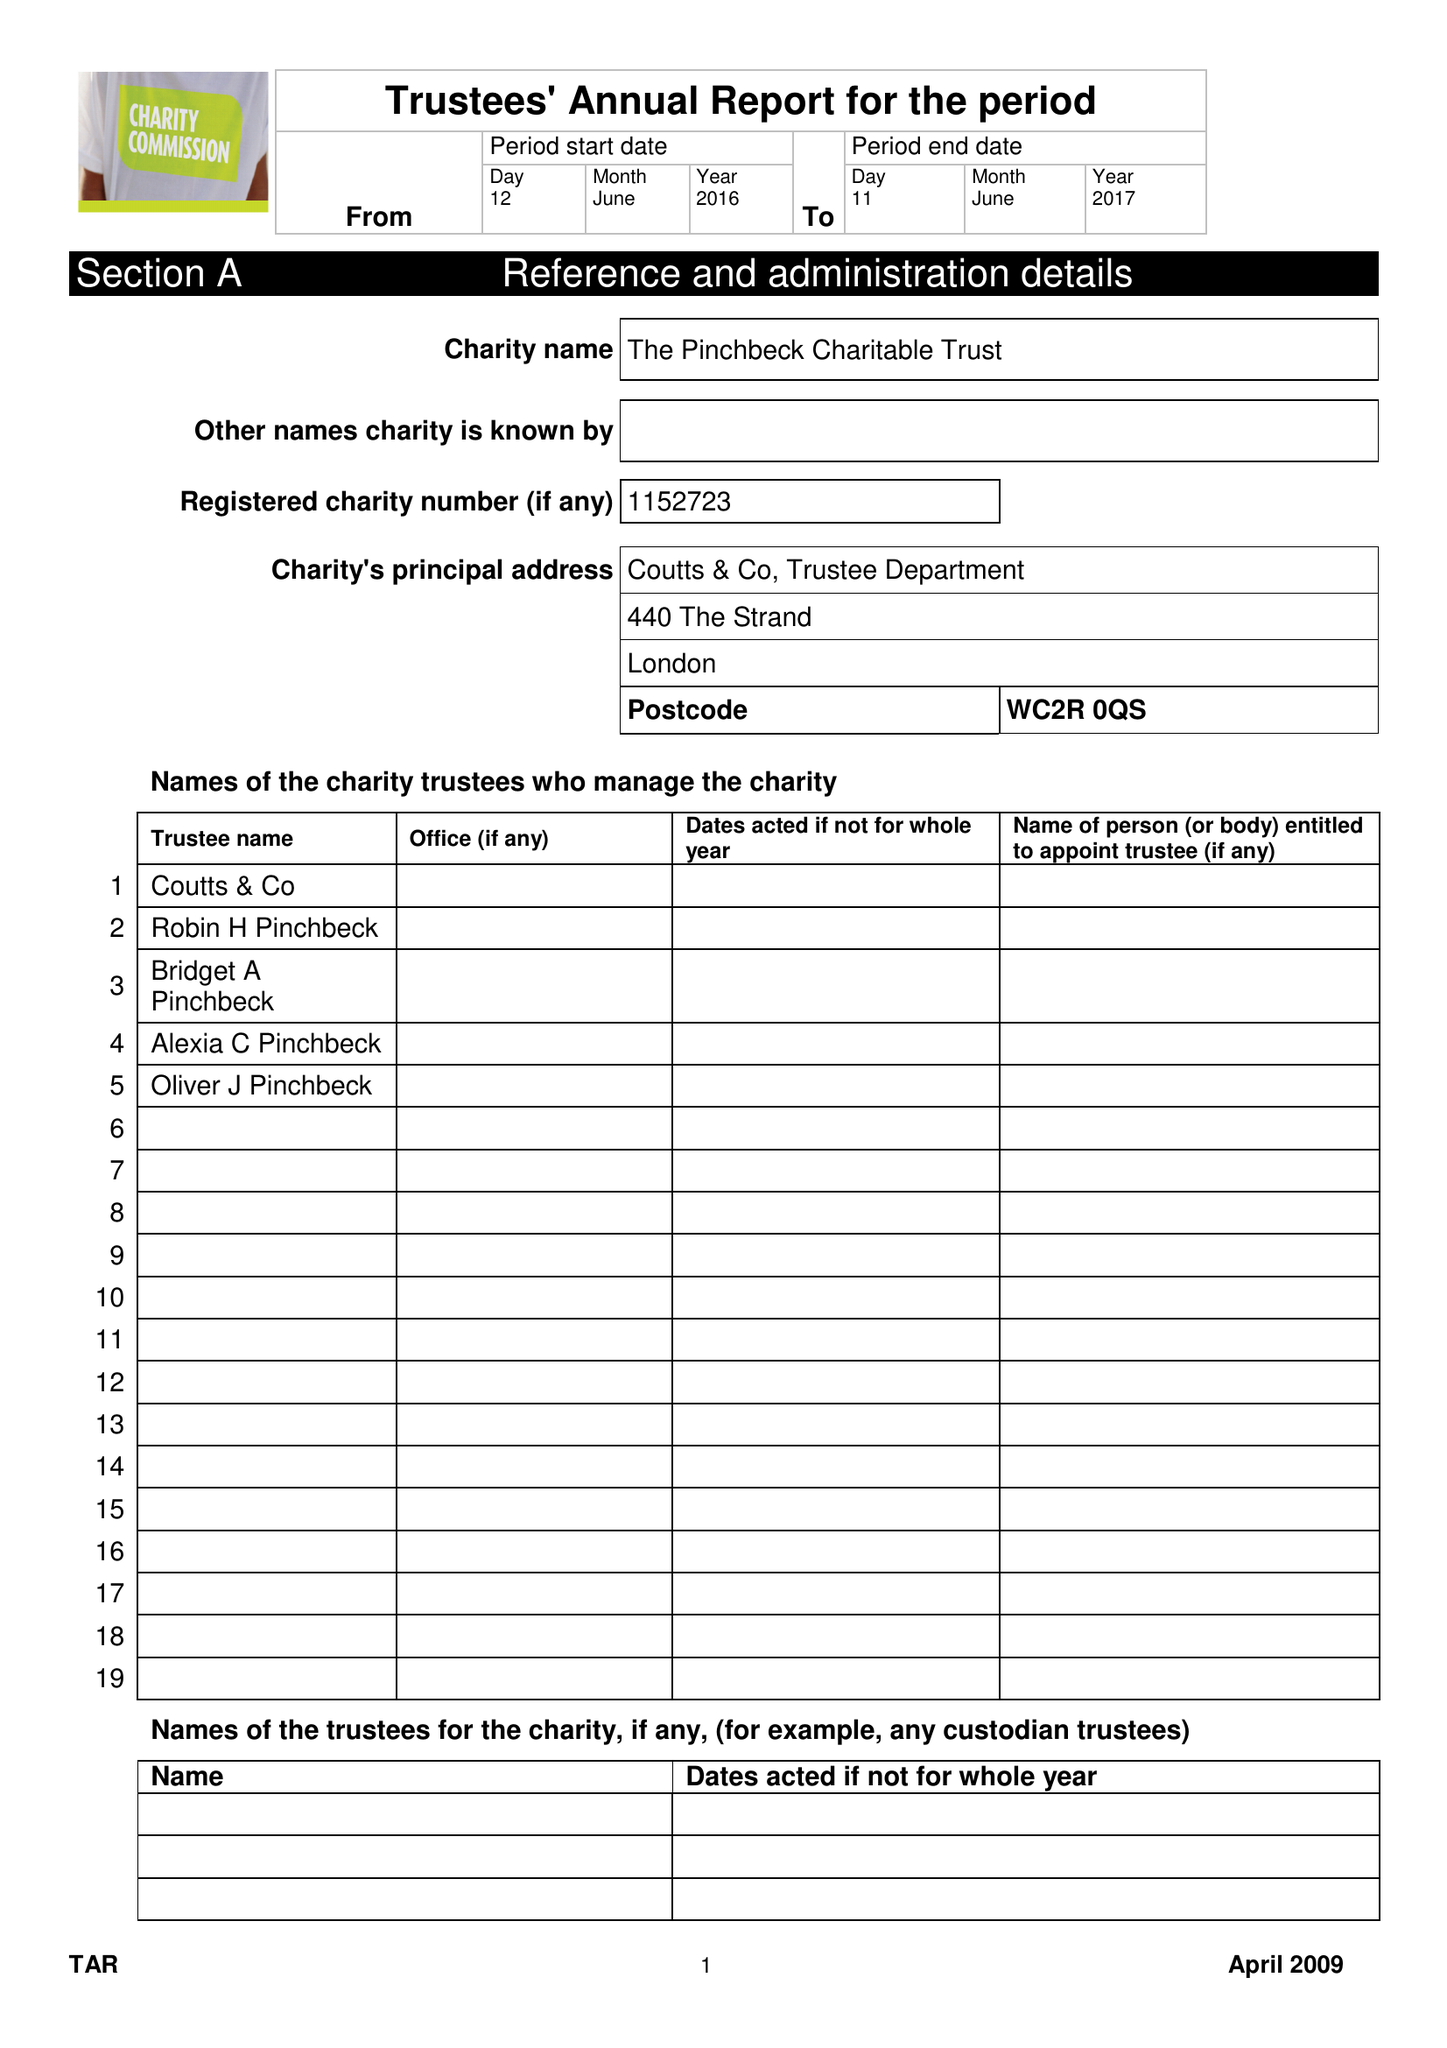What is the value for the address__postcode?
Answer the question using a single word or phrase. SW1H 9JA 